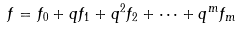<formula> <loc_0><loc_0><loc_500><loc_500>f = f _ { 0 } + q f _ { 1 } + q ^ { 2 } f _ { 2 } + \cdots + q ^ { m } f _ { m }</formula> 